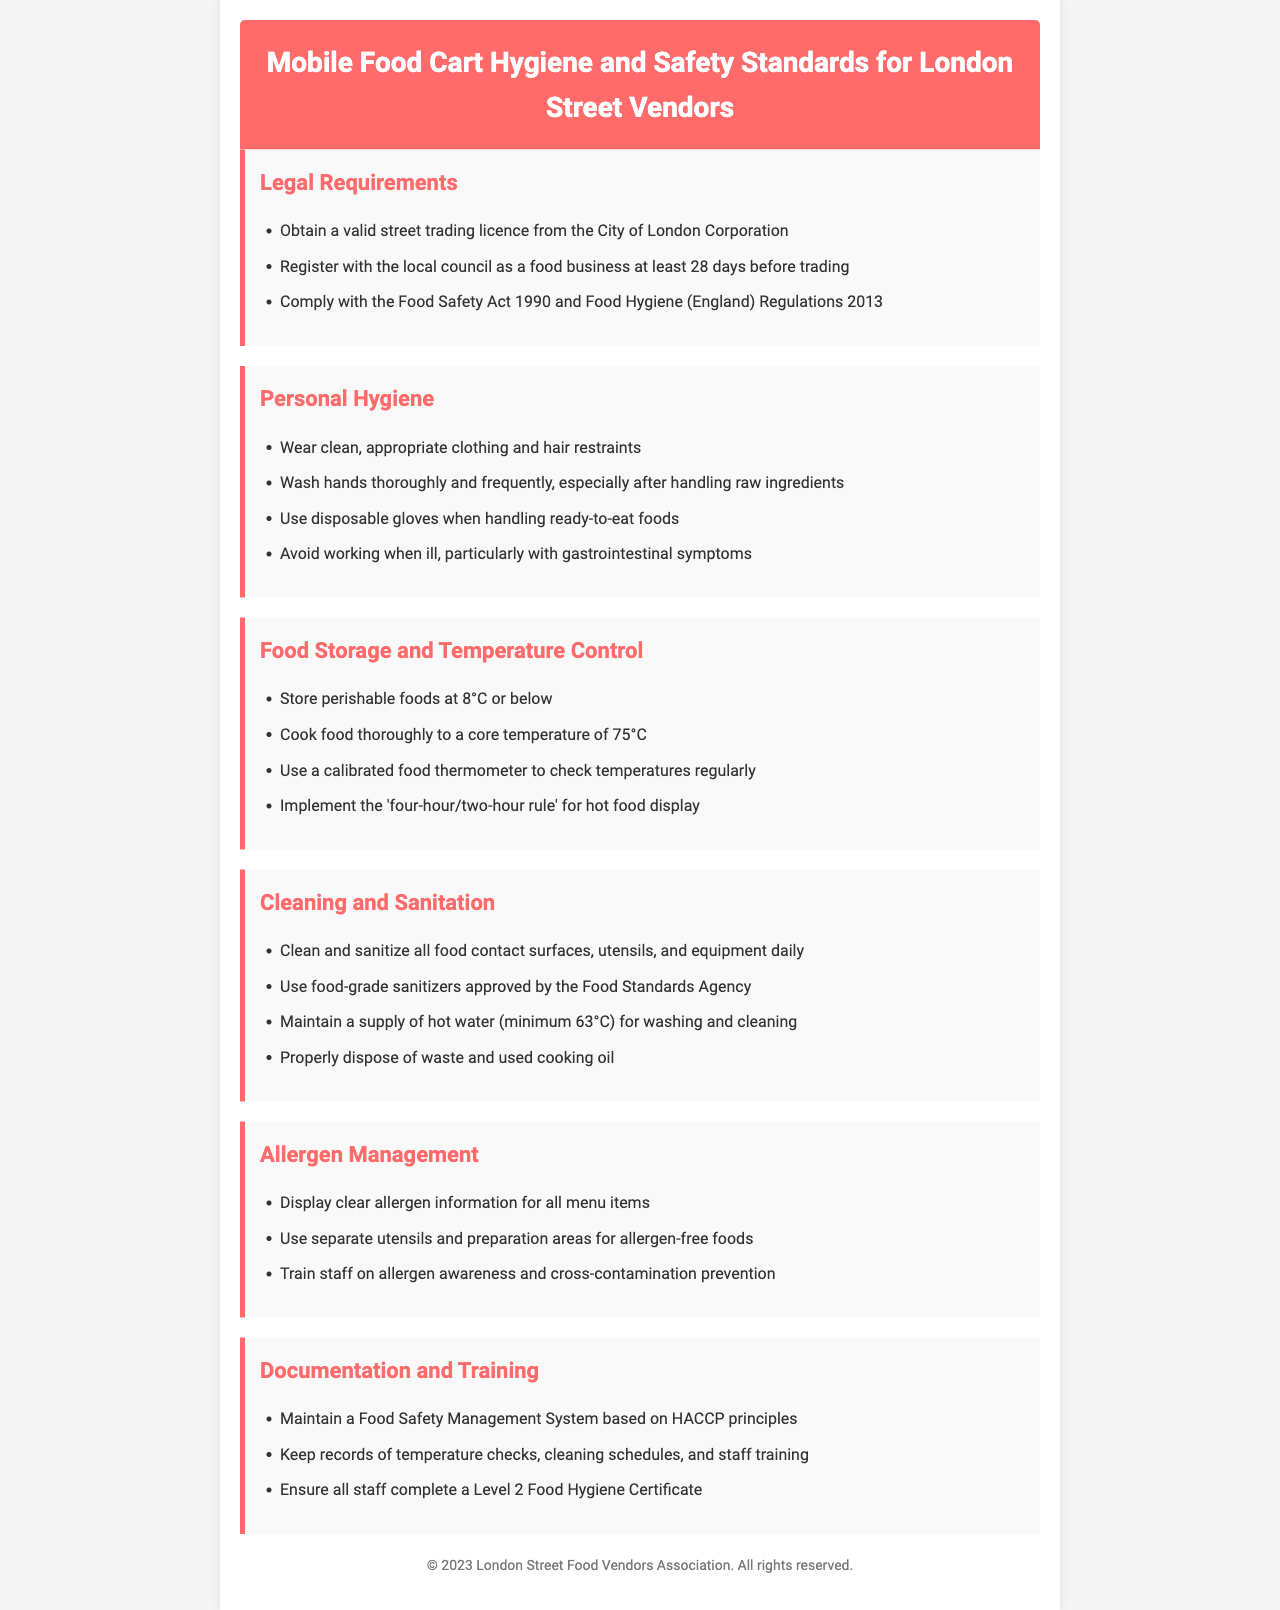What is the title of the document? The title is clearly stated at the top of the document, identifying its main subject for the readers.
Answer: Mobile Food Cart Hygiene and Safety Standards for London Street Vendors What should food be stored at? The document specifies the temperature that perishable foods must be stored to ensure safety.
Answer: 8°C or below What is the core cooking temperature? It indicates the minimum required temperature food must reach to be safely cooked.
Answer: 75°C What should gloves be used for? The document explains the circumstances under which gloves are necessary for handling food.
Answer: Handling ready-to-eat foods How often should food contact surfaces be cleaned? This question pertains to the cleaning frequency as stated in the safety standards for maintaining hygiene.
Answer: Daily How long before trading must a food business register? The document outlines the timeframe for registration before commencing food sales on the street.
Answer: 28 days What training certificate is required for staff? The document highlights the necessary certification that all food handlers are required to have.
Answer: Level 2 Food Hygiene Certificate What principle should the Food Safety Management System be based on? This question addresses the foundational aspect of the food safety management that vendors must comply with.
Answer: HACCP principles What should be displayed on the menu regarding allergens? The document stresses the importance of communication regarding allergens to customers for their safety.
Answer: Clear allergen information 